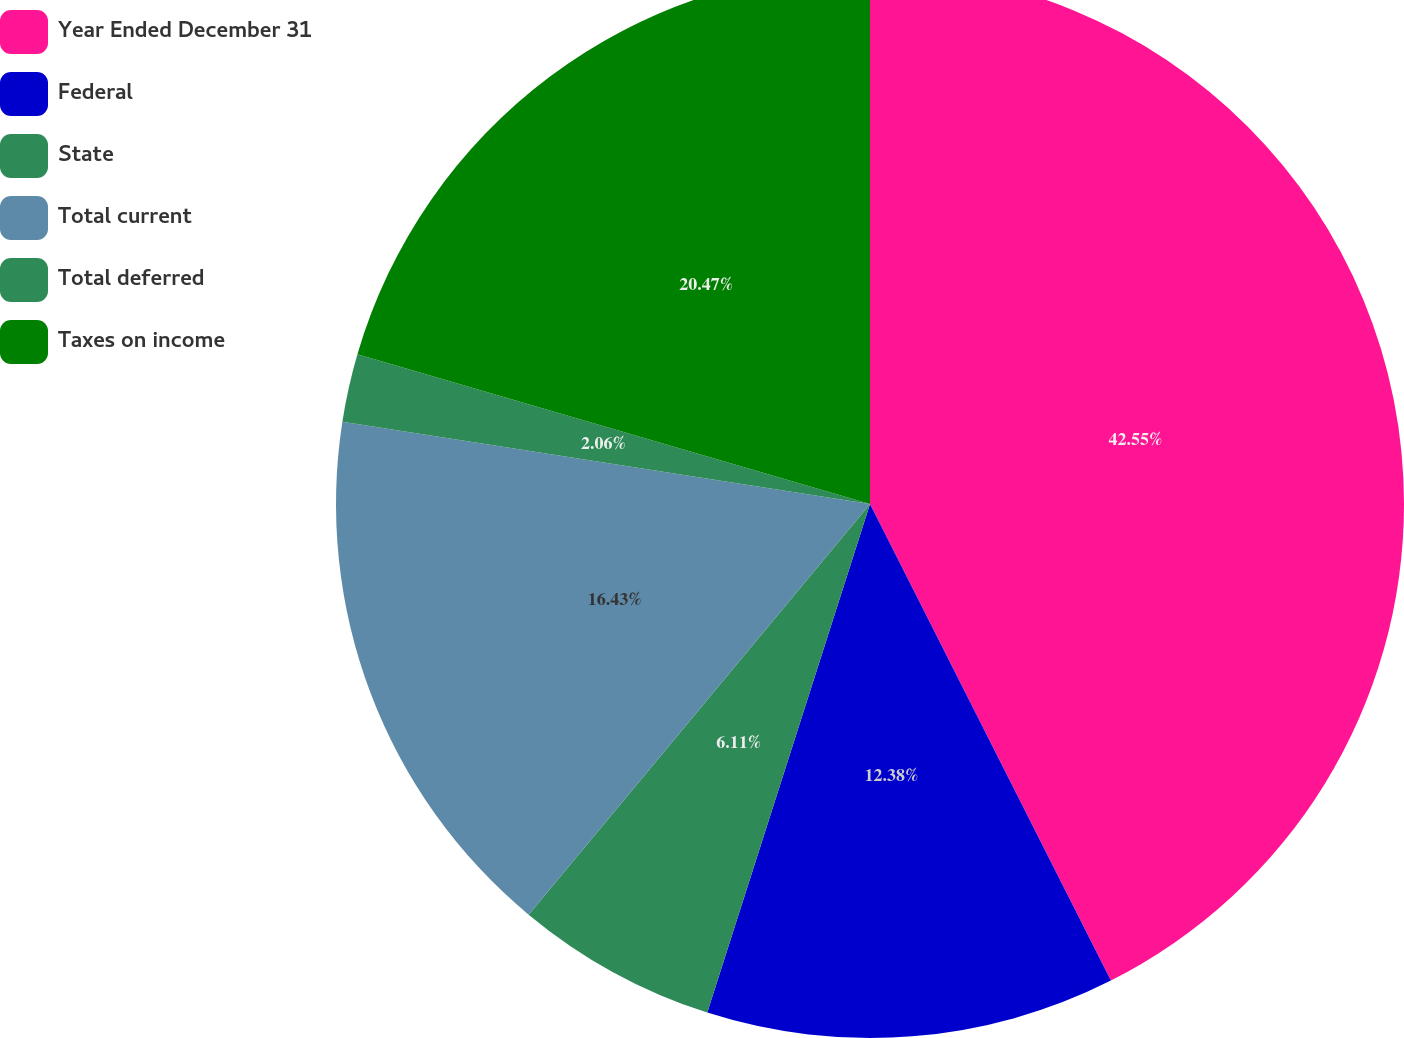Convert chart to OTSL. <chart><loc_0><loc_0><loc_500><loc_500><pie_chart><fcel>Year Ended December 31<fcel>Federal<fcel>State<fcel>Total current<fcel>Total deferred<fcel>Taxes on income<nl><fcel>42.56%<fcel>12.38%<fcel>6.11%<fcel>16.43%<fcel>2.06%<fcel>20.48%<nl></chart> 